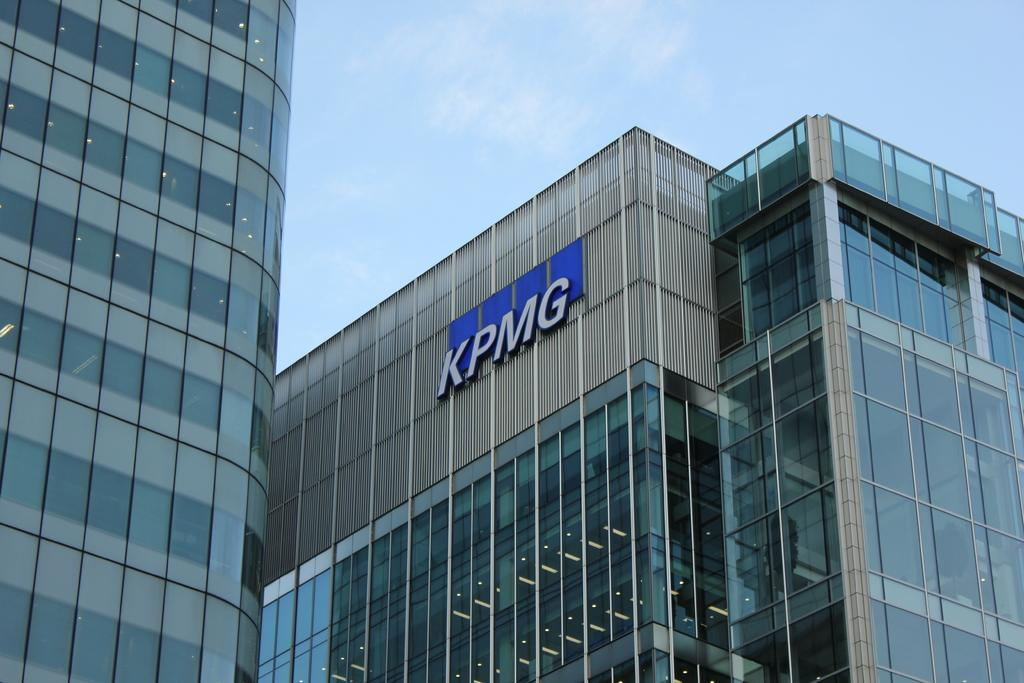What type of structures are present in the image? There are buildings in the image. What is the color of the buildings? The buildings are green in color. What can be seen in the background of the image? The sky is visible in the background of the image. What type of pet can be seen playing with a bucket in the image? There is no pet or bucket present in the image; it only features green buildings and the sky. 